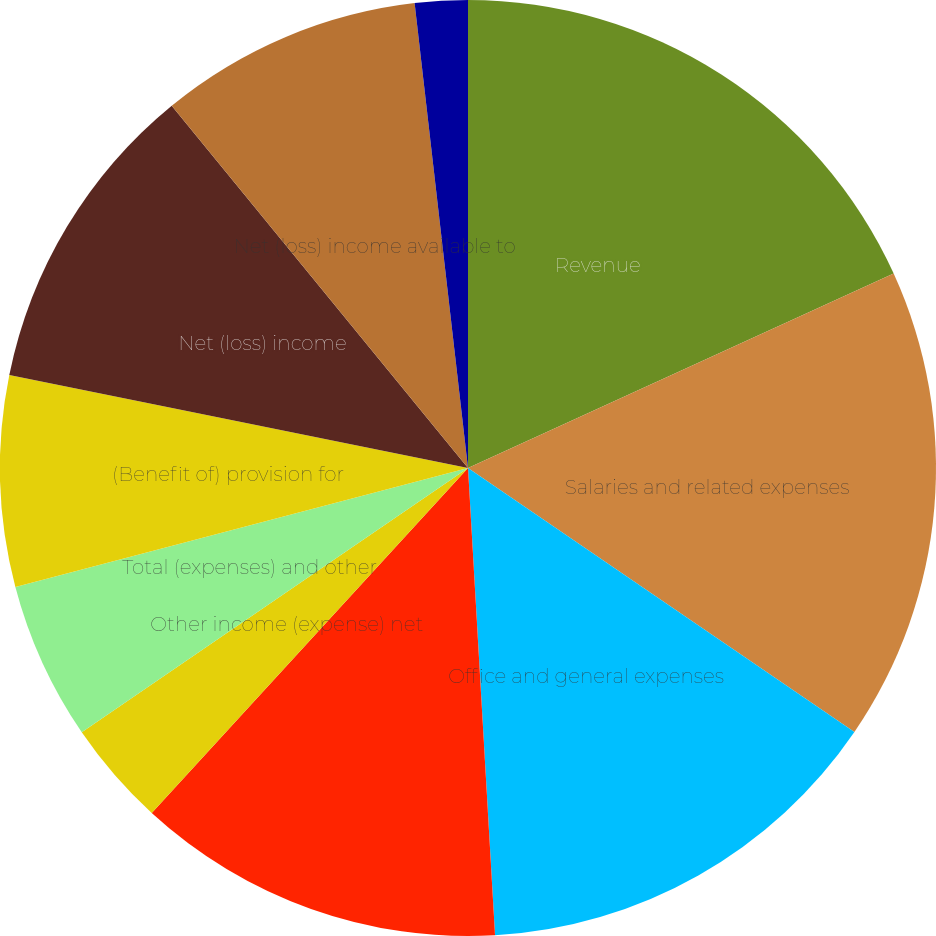Convert chart. <chart><loc_0><loc_0><loc_500><loc_500><pie_chart><fcel>Revenue<fcel>Salaries and related expenses<fcel>Office and general expenses<fcel>Operating (loss) income<fcel>Other income (expense) net<fcel>Total (expenses) and other<fcel>(Benefit of) provision for<fcel>Net (loss) income<fcel>Net (loss) income available to<fcel>Basic<nl><fcel>18.18%<fcel>16.36%<fcel>14.54%<fcel>12.73%<fcel>3.64%<fcel>5.46%<fcel>7.27%<fcel>10.91%<fcel>9.09%<fcel>1.82%<nl></chart> 